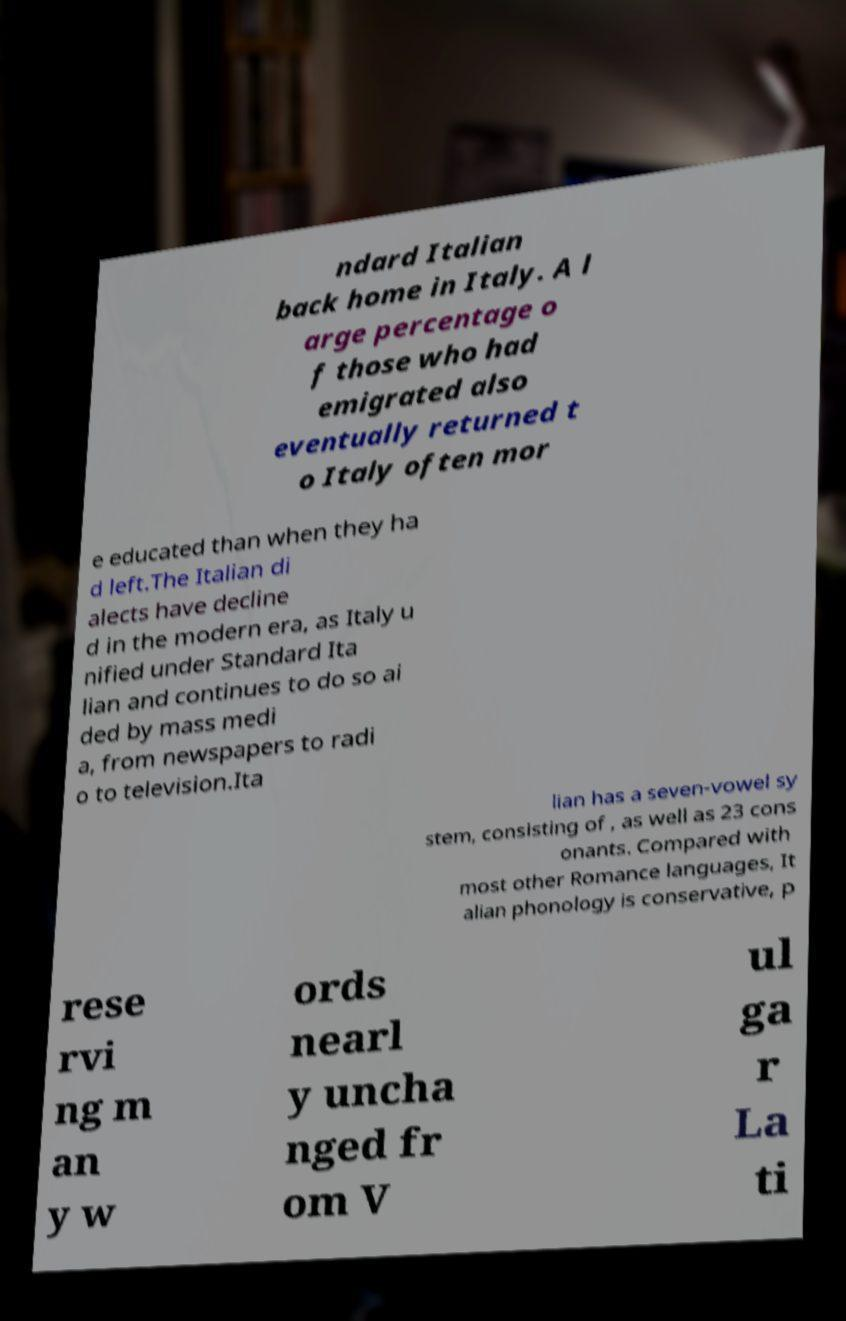For documentation purposes, I need the text within this image transcribed. Could you provide that? ndard Italian back home in Italy. A l arge percentage o f those who had emigrated also eventually returned t o Italy often mor e educated than when they ha d left.The Italian di alects have decline d in the modern era, as Italy u nified under Standard Ita lian and continues to do so ai ded by mass medi a, from newspapers to radi o to television.Ita lian has a seven-vowel sy stem, consisting of , as well as 23 cons onants. Compared with most other Romance languages, It alian phonology is conservative, p rese rvi ng m an y w ords nearl y uncha nged fr om V ul ga r La ti 